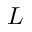Convert formula to latex. <formula><loc_0><loc_0><loc_500><loc_500>L</formula> 